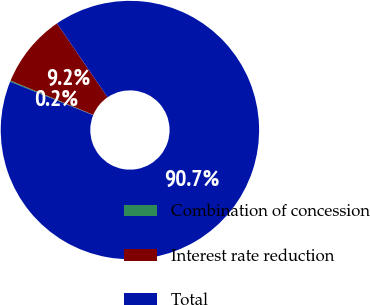Convert chart to OTSL. <chart><loc_0><loc_0><loc_500><loc_500><pie_chart><fcel>Combination of concession<fcel>Interest rate reduction<fcel>Total<nl><fcel>0.15%<fcel>9.2%<fcel>90.65%<nl></chart> 